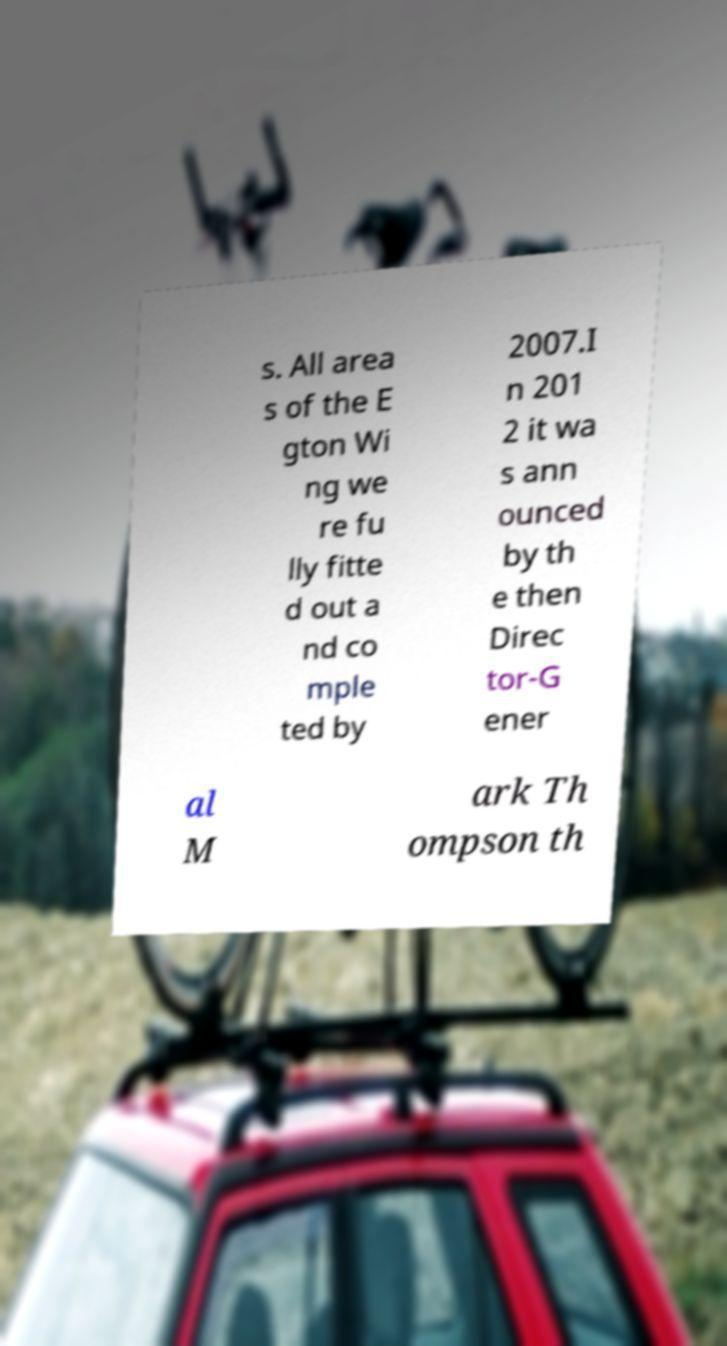What messages or text are displayed in this image? I need them in a readable, typed format. s. All area s of the E gton Wi ng we re fu lly fitte d out a nd co mple ted by 2007.I n 201 2 it wa s ann ounced by th e then Direc tor-G ener al M ark Th ompson th 